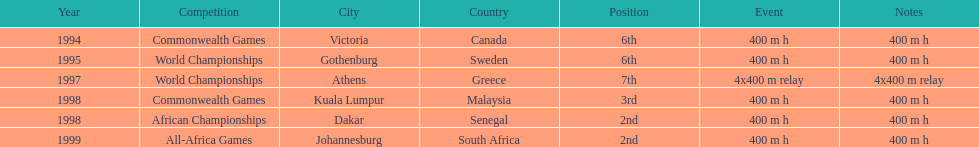In what years did ken harnden do better that 5th place? 1998, 1999. 